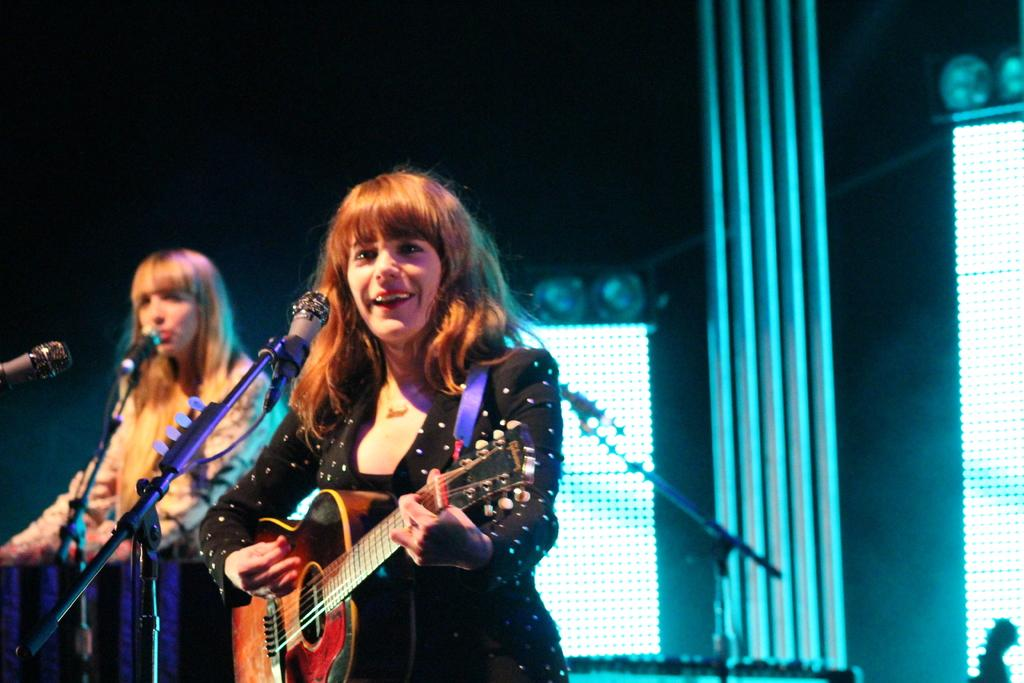How many people are in the image? There are two persons standing in the image. What is one of the persons holding? One person is holding a guitar. What object is present in the image that is typically used for amplifying sound? There is a microphone with a stand in the image. What color is the crayon that the tramp is using to write a message in the image? There is no crayon, tramp, or writing present in the image. 